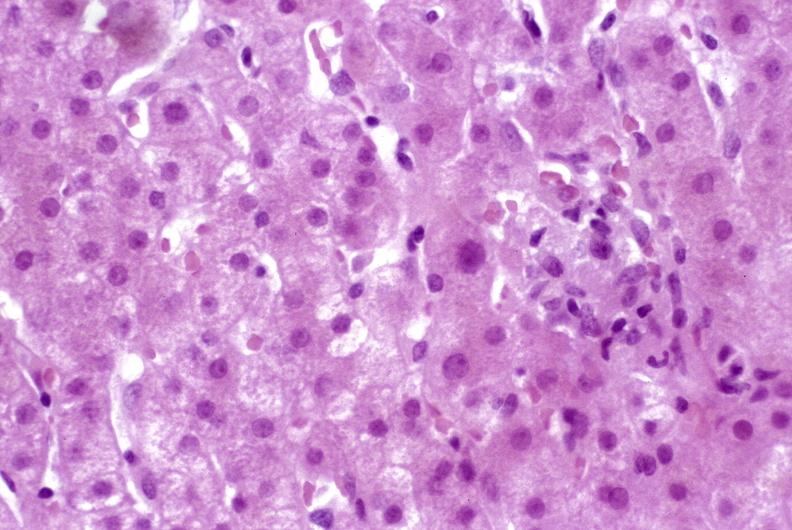what does this image show?
Answer the question using a single word or phrase. Granulomas 